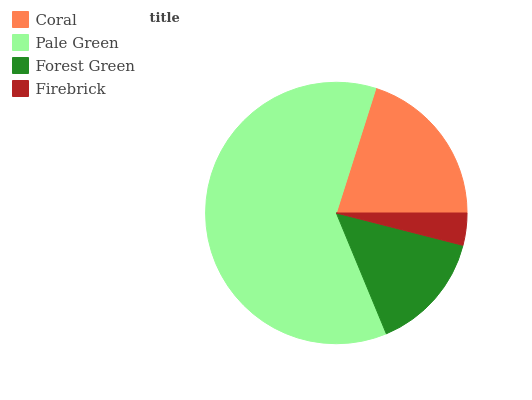Is Firebrick the minimum?
Answer yes or no. Yes. Is Pale Green the maximum?
Answer yes or no. Yes. Is Forest Green the minimum?
Answer yes or no. No. Is Forest Green the maximum?
Answer yes or no. No. Is Pale Green greater than Forest Green?
Answer yes or no. Yes. Is Forest Green less than Pale Green?
Answer yes or no. Yes. Is Forest Green greater than Pale Green?
Answer yes or no. No. Is Pale Green less than Forest Green?
Answer yes or no. No. Is Coral the high median?
Answer yes or no. Yes. Is Forest Green the low median?
Answer yes or no. Yes. Is Pale Green the high median?
Answer yes or no. No. Is Coral the low median?
Answer yes or no. No. 